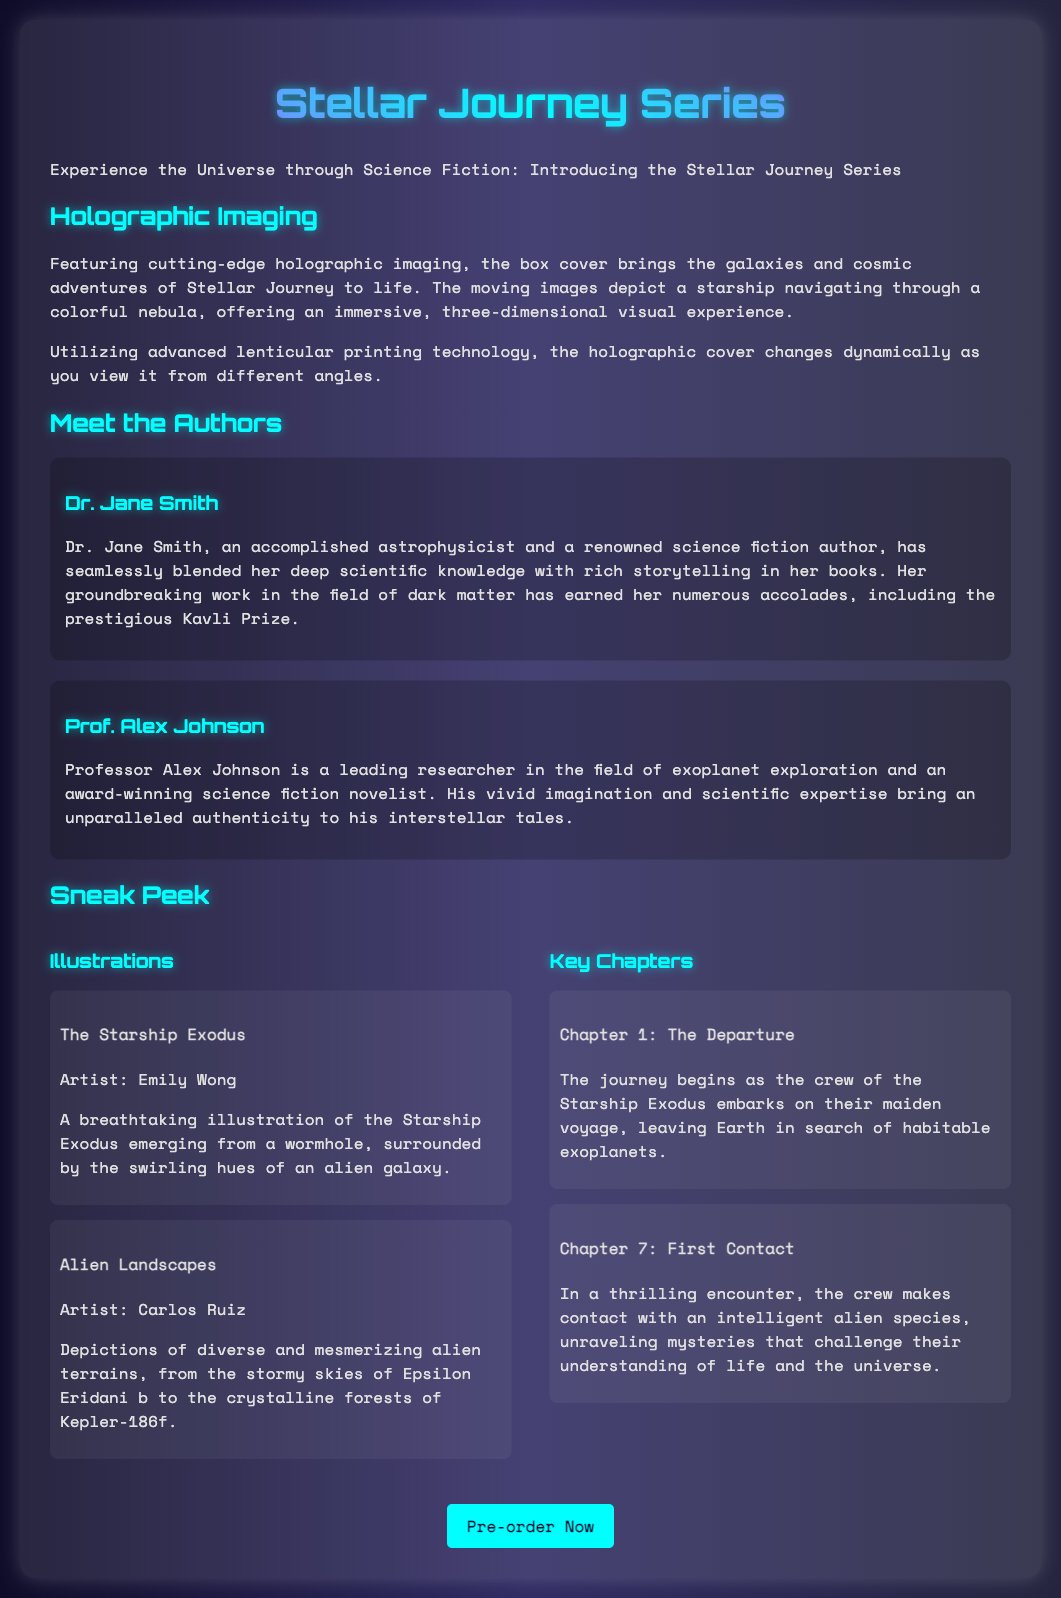What is the title of the book series? The title of the book series is explicitly mentioned at the top of the document.
Answer: Stellar Journey Series Who are the authors featured in the box set? The document provides the names of both authors in the "Meet the Authors" section.
Answer: Dr. Jane Smith, Prof. Alex Johnson What is the name of the artist for "The Starship Exodus" illustration? The artist's name is provided in the description of the illustration within the sneak peek section.
Answer: Emily Wong What chapter is titled "First Contact"? The chapter names are listed along with their respective numbers in the key chapters section.
Answer: Chapter 7 What is the main technological feature of the box cover? The document describes the prominent technological feature in the holographic imaging section.
Answer: Holographic imaging What prize has Dr. Jane Smith won? The document notes the award received by Dr. Jane Smith in her biography.
Answer: Kavli Prize 